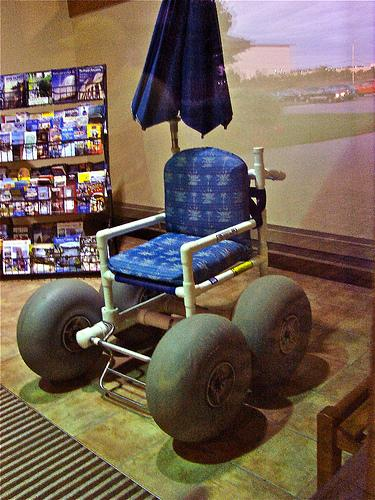What is attached to the chair? wheels 